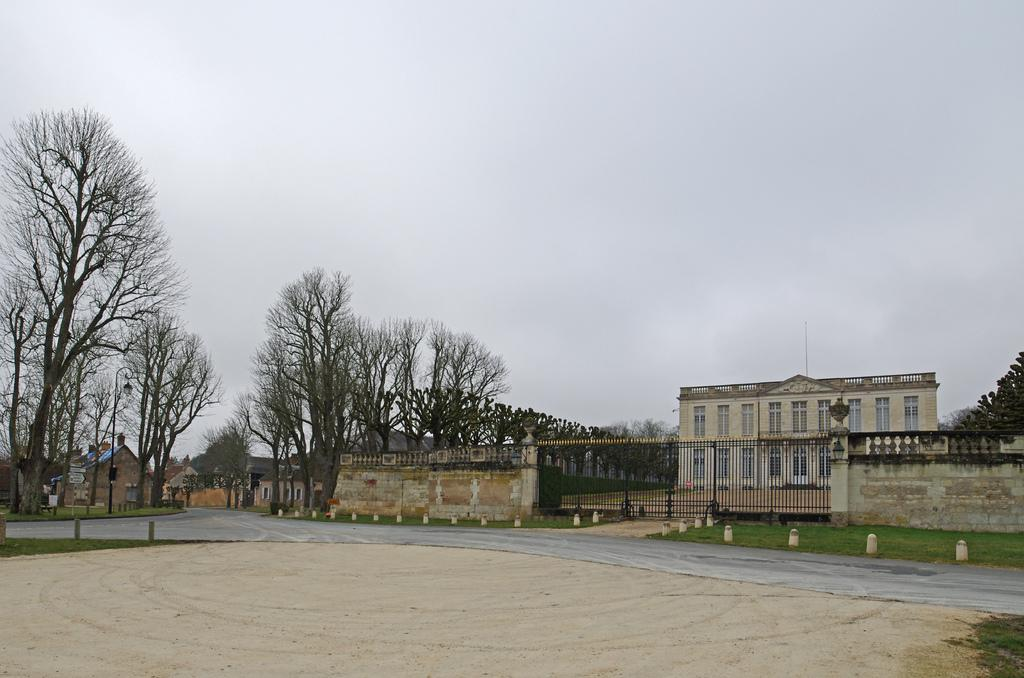What type of road is shown in the image? There is a 3-way road in the image. What else can be seen in the image besides the road? There are buildings, trees, and a gate on the right side of the image. Where is the gate located in relation to the road? The gate is on the right side of the image. What is visible at the top of the image? The sky is visible at the top of the image. How many boys are holding pens in the image? There are no boys or pens present in the image. Is there a judge visible in the image? There is no judge present in the image. 